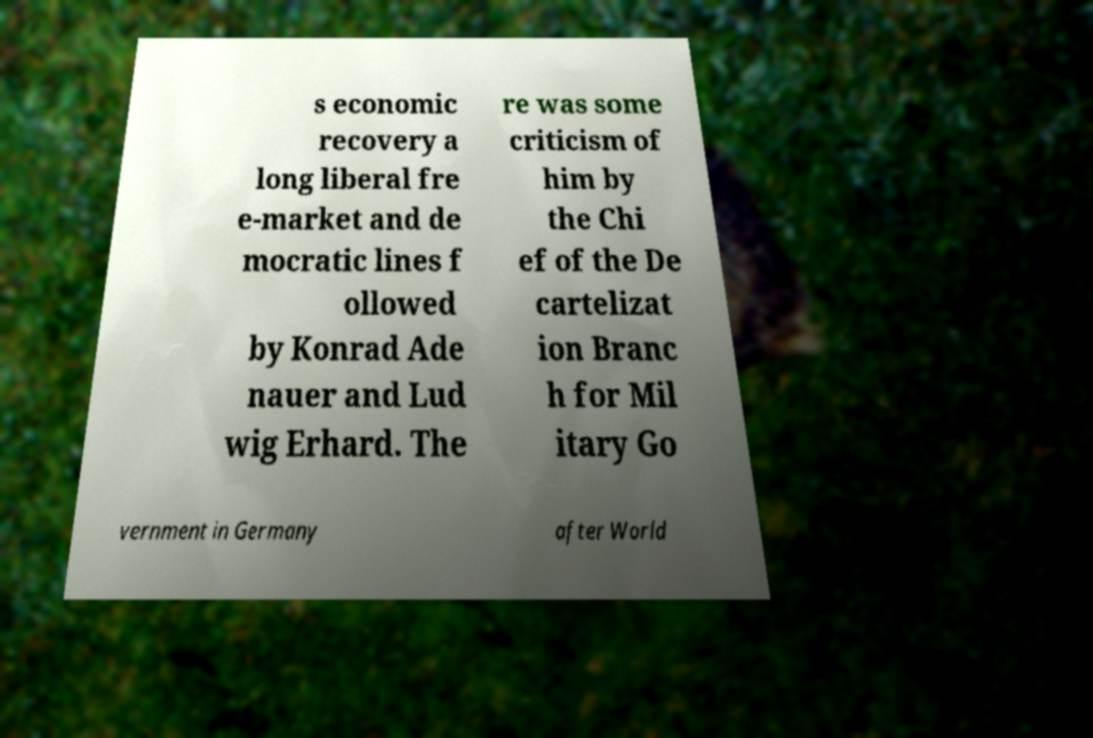Please identify and transcribe the text found in this image. s economic recovery a long liberal fre e-market and de mocratic lines f ollowed by Konrad Ade nauer and Lud wig Erhard. The re was some criticism of him by the Chi ef of the De cartelizat ion Branc h for Mil itary Go vernment in Germany after World 